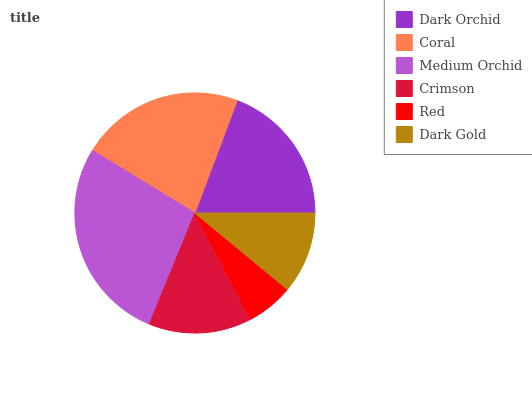Is Red the minimum?
Answer yes or no. Yes. Is Medium Orchid the maximum?
Answer yes or no. Yes. Is Coral the minimum?
Answer yes or no. No. Is Coral the maximum?
Answer yes or no. No. Is Coral greater than Dark Orchid?
Answer yes or no. Yes. Is Dark Orchid less than Coral?
Answer yes or no. Yes. Is Dark Orchid greater than Coral?
Answer yes or no. No. Is Coral less than Dark Orchid?
Answer yes or no. No. Is Dark Orchid the high median?
Answer yes or no. Yes. Is Crimson the low median?
Answer yes or no. Yes. Is Dark Gold the high median?
Answer yes or no. No. Is Dark Gold the low median?
Answer yes or no. No. 